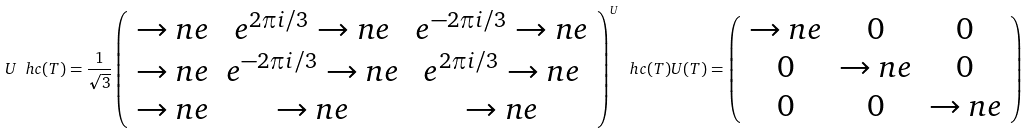Convert formula to latex. <formula><loc_0><loc_0><loc_500><loc_500>U \ h c ( T ) = \frac { 1 } { \sqrt { 3 } } \left ( \begin{array} { c c c } \to n e & e ^ { 2 \pi i / 3 } \to n e & e ^ { - 2 \pi i / 3 } \to n e \\ \to n e & e ^ { - 2 \pi i / 3 } \to n e & e ^ { 2 \pi i / 3 } \to n e \\ \to n e & \to n e & \to n e \end{array} \right ) ^ { U } \ h c ( T ) U ( T ) = \left ( \begin{array} { c c c } \to n e & 0 & 0 \\ 0 & \to n e & 0 \\ 0 & 0 & \to n e \end{array} \right )</formula> 